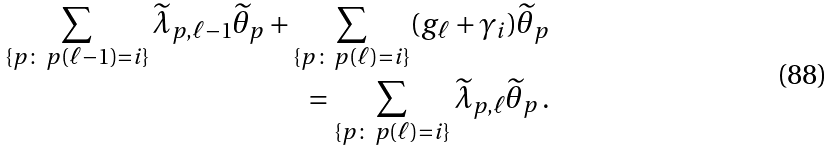<formula> <loc_0><loc_0><loc_500><loc_500>\sum _ { \{ { p } \colon \, p ( \ell - 1 ) = i \} } \widetilde { \lambda } _ { { p } , \ell - 1 } \widetilde { \theta } _ { p } + \sum _ { \{ { p } \colon \, { p } ( \ell ) = i \} } ( g _ { \ell } + \gamma _ { i } ) \widetilde { \theta } _ { p } \\ = \sum _ { \{ { p } \colon \, { p } ( \ell ) = i \} } \widetilde { \lambda } _ { { p } , \ell } \widetilde { \theta } _ { p } \, .</formula> 